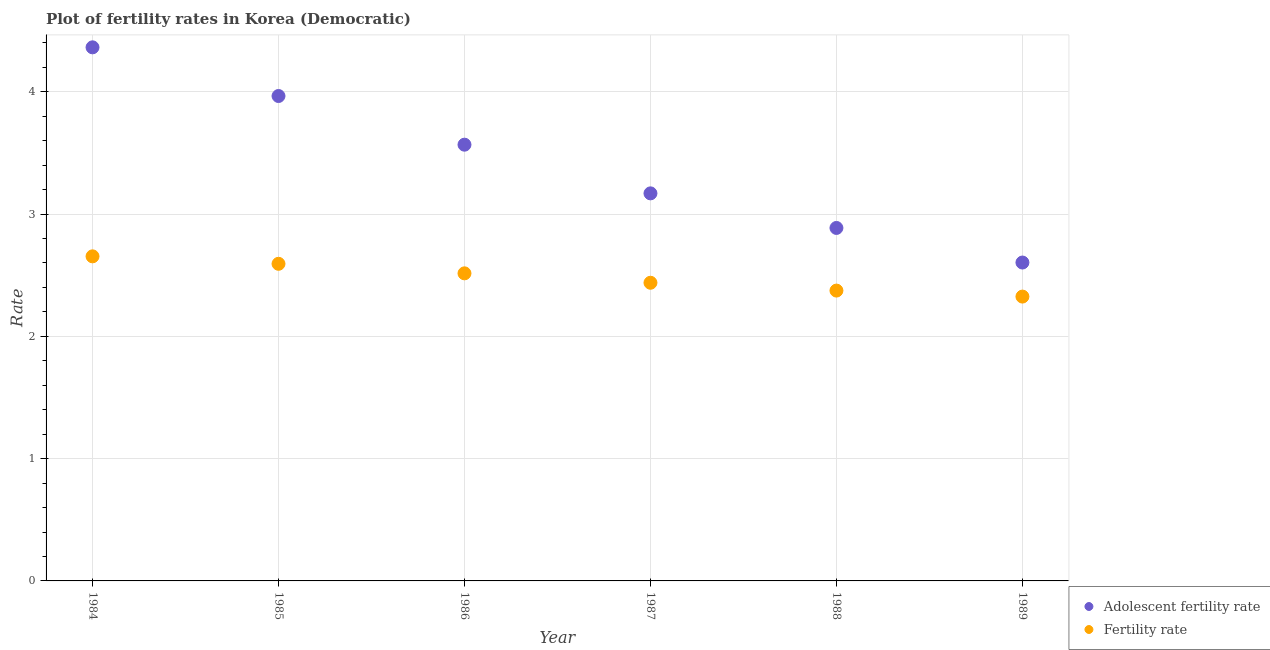Is the number of dotlines equal to the number of legend labels?
Provide a short and direct response. Yes. What is the adolescent fertility rate in 1984?
Your answer should be compact. 4.36. Across all years, what is the maximum adolescent fertility rate?
Your response must be concise. 4.36. Across all years, what is the minimum fertility rate?
Ensure brevity in your answer.  2.33. What is the total adolescent fertility rate in the graph?
Make the answer very short. 20.55. What is the difference between the fertility rate in 1987 and that in 1988?
Offer a very short reply. 0.06. What is the difference between the adolescent fertility rate in 1987 and the fertility rate in 1984?
Make the answer very short. 0.52. What is the average adolescent fertility rate per year?
Your answer should be very brief. 3.43. In the year 1988, what is the difference between the adolescent fertility rate and fertility rate?
Ensure brevity in your answer.  0.51. What is the ratio of the adolescent fertility rate in 1986 to that in 1988?
Provide a succinct answer. 1.24. Is the difference between the adolescent fertility rate in 1986 and 1987 greater than the difference between the fertility rate in 1986 and 1987?
Make the answer very short. Yes. What is the difference between the highest and the second highest adolescent fertility rate?
Your response must be concise. 0.4. What is the difference between the highest and the lowest adolescent fertility rate?
Your answer should be very brief. 1.76. Is the sum of the adolescent fertility rate in 1985 and 1989 greater than the maximum fertility rate across all years?
Provide a succinct answer. Yes. Does the fertility rate monotonically increase over the years?
Provide a short and direct response. No. What is the difference between two consecutive major ticks on the Y-axis?
Make the answer very short. 1. Are the values on the major ticks of Y-axis written in scientific E-notation?
Offer a terse response. No. Does the graph contain grids?
Keep it short and to the point. Yes. Where does the legend appear in the graph?
Your answer should be very brief. Bottom right. What is the title of the graph?
Your answer should be very brief. Plot of fertility rates in Korea (Democratic). What is the label or title of the Y-axis?
Your answer should be very brief. Rate. What is the Rate in Adolescent fertility rate in 1984?
Ensure brevity in your answer.  4.36. What is the Rate of Fertility rate in 1984?
Your answer should be very brief. 2.65. What is the Rate in Adolescent fertility rate in 1985?
Offer a terse response. 3.96. What is the Rate in Fertility rate in 1985?
Keep it short and to the point. 2.59. What is the Rate of Adolescent fertility rate in 1986?
Offer a very short reply. 3.57. What is the Rate in Fertility rate in 1986?
Your answer should be compact. 2.52. What is the Rate in Adolescent fertility rate in 1987?
Give a very brief answer. 3.17. What is the Rate in Fertility rate in 1987?
Your response must be concise. 2.44. What is the Rate of Adolescent fertility rate in 1988?
Make the answer very short. 2.89. What is the Rate of Fertility rate in 1988?
Ensure brevity in your answer.  2.37. What is the Rate in Adolescent fertility rate in 1989?
Your answer should be compact. 2.6. What is the Rate of Fertility rate in 1989?
Keep it short and to the point. 2.33. Across all years, what is the maximum Rate of Adolescent fertility rate?
Make the answer very short. 4.36. Across all years, what is the maximum Rate of Fertility rate?
Keep it short and to the point. 2.65. Across all years, what is the minimum Rate in Adolescent fertility rate?
Provide a short and direct response. 2.6. Across all years, what is the minimum Rate of Fertility rate?
Your response must be concise. 2.33. What is the total Rate of Adolescent fertility rate in the graph?
Your answer should be very brief. 20.55. What is the total Rate of Fertility rate in the graph?
Offer a very short reply. 14.9. What is the difference between the Rate of Adolescent fertility rate in 1984 and that in 1985?
Keep it short and to the point. 0.4. What is the difference between the Rate of Fertility rate in 1984 and that in 1985?
Your response must be concise. 0.06. What is the difference between the Rate in Adolescent fertility rate in 1984 and that in 1986?
Ensure brevity in your answer.  0.8. What is the difference between the Rate in Fertility rate in 1984 and that in 1986?
Make the answer very short. 0.14. What is the difference between the Rate in Adolescent fertility rate in 1984 and that in 1987?
Make the answer very short. 1.19. What is the difference between the Rate in Fertility rate in 1984 and that in 1987?
Provide a succinct answer. 0.22. What is the difference between the Rate of Adolescent fertility rate in 1984 and that in 1988?
Offer a terse response. 1.48. What is the difference between the Rate in Fertility rate in 1984 and that in 1988?
Your answer should be very brief. 0.28. What is the difference between the Rate in Adolescent fertility rate in 1984 and that in 1989?
Offer a very short reply. 1.76. What is the difference between the Rate of Fertility rate in 1984 and that in 1989?
Your answer should be compact. 0.33. What is the difference between the Rate in Adolescent fertility rate in 1985 and that in 1986?
Your answer should be very brief. 0.4. What is the difference between the Rate of Fertility rate in 1985 and that in 1986?
Your answer should be compact. 0.08. What is the difference between the Rate of Adolescent fertility rate in 1985 and that in 1987?
Give a very brief answer. 0.8. What is the difference between the Rate of Fertility rate in 1985 and that in 1987?
Ensure brevity in your answer.  0.15. What is the difference between the Rate of Adolescent fertility rate in 1985 and that in 1988?
Give a very brief answer. 1.08. What is the difference between the Rate in Fertility rate in 1985 and that in 1988?
Provide a short and direct response. 0.22. What is the difference between the Rate of Adolescent fertility rate in 1985 and that in 1989?
Offer a terse response. 1.36. What is the difference between the Rate of Fertility rate in 1985 and that in 1989?
Make the answer very short. 0.27. What is the difference between the Rate of Adolescent fertility rate in 1986 and that in 1987?
Your answer should be compact. 0.4. What is the difference between the Rate in Fertility rate in 1986 and that in 1987?
Make the answer very short. 0.08. What is the difference between the Rate in Adolescent fertility rate in 1986 and that in 1988?
Your answer should be very brief. 0.68. What is the difference between the Rate in Fertility rate in 1986 and that in 1988?
Your response must be concise. 0.14. What is the difference between the Rate in Adolescent fertility rate in 1986 and that in 1989?
Your answer should be very brief. 0.96. What is the difference between the Rate of Fertility rate in 1986 and that in 1989?
Make the answer very short. 0.19. What is the difference between the Rate of Adolescent fertility rate in 1987 and that in 1988?
Offer a terse response. 0.28. What is the difference between the Rate of Fertility rate in 1987 and that in 1988?
Keep it short and to the point. 0.06. What is the difference between the Rate in Adolescent fertility rate in 1987 and that in 1989?
Make the answer very short. 0.57. What is the difference between the Rate in Fertility rate in 1987 and that in 1989?
Keep it short and to the point. 0.11. What is the difference between the Rate of Adolescent fertility rate in 1988 and that in 1989?
Your response must be concise. 0.28. What is the difference between the Rate of Fertility rate in 1988 and that in 1989?
Your response must be concise. 0.05. What is the difference between the Rate of Adolescent fertility rate in 1984 and the Rate of Fertility rate in 1985?
Offer a terse response. 1.77. What is the difference between the Rate of Adolescent fertility rate in 1984 and the Rate of Fertility rate in 1986?
Make the answer very short. 1.85. What is the difference between the Rate in Adolescent fertility rate in 1984 and the Rate in Fertility rate in 1987?
Make the answer very short. 1.93. What is the difference between the Rate of Adolescent fertility rate in 1984 and the Rate of Fertility rate in 1988?
Offer a terse response. 1.99. What is the difference between the Rate in Adolescent fertility rate in 1984 and the Rate in Fertility rate in 1989?
Provide a short and direct response. 2.04. What is the difference between the Rate of Adolescent fertility rate in 1985 and the Rate of Fertility rate in 1986?
Your response must be concise. 1.45. What is the difference between the Rate of Adolescent fertility rate in 1985 and the Rate of Fertility rate in 1987?
Keep it short and to the point. 1.53. What is the difference between the Rate of Adolescent fertility rate in 1985 and the Rate of Fertility rate in 1988?
Provide a short and direct response. 1.59. What is the difference between the Rate in Adolescent fertility rate in 1985 and the Rate in Fertility rate in 1989?
Keep it short and to the point. 1.64. What is the difference between the Rate of Adolescent fertility rate in 1986 and the Rate of Fertility rate in 1987?
Ensure brevity in your answer.  1.13. What is the difference between the Rate of Adolescent fertility rate in 1986 and the Rate of Fertility rate in 1988?
Offer a terse response. 1.19. What is the difference between the Rate of Adolescent fertility rate in 1986 and the Rate of Fertility rate in 1989?
Provide a short and direct response. 1.24. What is the difference between the Rate in Adolescent fertility rate in 1987 and the Rate in Fertility rate in 1988?
Provide a short and direct response. 0.8. What is the difference between the Rate in Adolescent fertility rate in 1987 and the Rate in Fertility rate in 1989?
Ensure brevity in your answer.  0.84. What is the difference between the Rate in Adolescent fertility rate in 1988 and the Rate in Fertility rate in 1989?
Keep it short and to the point. 0.56. What is the average Rate of Adolescent fertility rate per year?
Provide a short and direct response. 3.43. What is the average Rate of Fertility rate per year?
Give a very brief answer. 2.48. In the year 1984, what is the difference between the Rate in Adolescent fertility rate and Rate in Fertility rate?
Your answer should be compact. 1.71. In the year 1985, what is the difference between the Rate of Adolescent fertility rate and Rate of Fertility rate?
Your answer should be compact. 1.37. In the year 1986, what is the difference between the Rate of Adolescent fertility rate and Rate of Fertility rate?
Give a very brief answer. 1.05. In the year 1987, what is the difference between the Rate in Adolescent fertility rate and Rate in Fertility rate?
Your answer should be compact. 0.73. In the year 1988, what is the difference between the Rate in Adolescent fertility rate and Rate in Fertility rate?
Your answer should be compact. 0.51. In the year 1989, what is the difference between the Rate in Adolescent fertility rate and Rate in Fertility rate?
Give a very brief answer. 0.28. What is the ratio of the Rate of Adolescent fertility rate in 1984 to that in 1985?
Offer a terse response. 1.1. What is the ratio of the Rate in Fertility rate in 1984 to that in 1985?
Give a very brief answer. 1.02. What is the ratio of the Rate of Adolescent fertility rate in 1984 to that in 1986?
Offer a very short reply. 1.22. What is the ratio of the Rate of Fertility rate in 1984 to that in 1986?
Provide a short and direct response. 1.06. What is the ratio of the Rate of Adolescent fertility rate in 1984 to that in 1987?
Make the answer very short. 1.38. What is the ratio of the Rate of Fertility rate in 1984 to that in 1987?
Keep it short and to the point. 1.09. What is the ratio of the Rate of Adolescent fertility rate in 1984 to that in 1988?
Provide a succinct answer. 1.51. What is the ratio of the Rate in Fertility rate in 1984 to that in 1988?
Your answer should be compact. 1.12. What is the ratio of the Rate of Adolescent fertility rate in 1984 to that in 1989?
Give a very brief answer. 1.68. What is the ratio of the Rate in Fertility rate in 1984 to that in 1989?
Your answer should be very brief. 1.14. What is the ratio of the Rate in Adolescent fertility rate in 1985 to that in 1986?
Give a very brief answer. 1.11. What is the ratio of the Rate in Fertility rate in 1985 to that in 1986?
Your response must be concise. 1.03. What is the ratio of the Rate of Adolescent fertility rate in 1985 to that in 1987?
Provide a short and direct response. 1.25. What is the ratio of the Rate of Fertility rate in 1985 to that in 1987?
Keep it short and to the point. 1.06. What is the ratio of the Rate of Adolescent fertility rate in 1985 to that in 1988?
Provide a succinct answer. 1.37. What is the ratio of the Rate of Fertility rate in 1985 to that in 1988?
Make the answer very short. 1.09. What is the ratio of the Rate in Adolescent fertility rate in 1985 to that in 1989?
Your answer should be very brief. 1.52. What is the ratio of the Rate of Fertility rate in 1985 to that in 1989?
Your answer should be very brief. 1.12. What is the ratio of the Rate of Adolescent fertility rate in 1986 to that in 1987?
Provide a short and direct response. 1.13. What is the ratio of the Rate of Fertility rate in 1986 to that in 1987?
Your response must be concise. 1.03. What is the ratio of the Rate in Adolescent fertility rate in 1986 to that in 1988?
Offer a very short reply. 1.24. What is the ratio of the Rate of Fertility rate in 1986 to that in 1988?
Ensure brevity in your answer.  1.06. What is the ratio of the Rate of Adolescent fertility rate in 1986 to that in 1989?
Offer a very short reply. 1.37. What is the ratio of the Rate in Fertility rate in 1986 to that in 1989?
Give a very brief answer. 1.08. What is the ratio of the Rate in Adolescent fertility rate in 1987 to that in 1988?
Your response must be concise. 1.1. What is the ratio of the Rate in Adolescent fertility rate in 1987 to that in 1989?
Provide a short and direct response. 1.22. What is the ratio of the Rate of Fertility rate in 1987 to that in 1989?
Keep it short and to the point. 1.05. What is the ratio of the Rate of Adolescent fertility rate in 1988 to that in 1989?
Your answer should be very brief. 1.11. What is the ratio of the Rate of Fertility rate in 1988 to that in 1989?
Your answer should be compact. 1.02. What is the difference between the highest and the second highest Rate in Adolescent fertility rate?
Your response must be concise. 0.4. What is the difference between the highest and the second highest Rate of Fertility rate?
Give a very brief answer. 0.06. What is the difference between the highest and the lowest Rate of Adolescent fertility rate?
Keep it short and to the point. 1.76. What is the difference between the highest and the lowest Rate of Fertility rate?
Your answer should be compact. 0.33. 